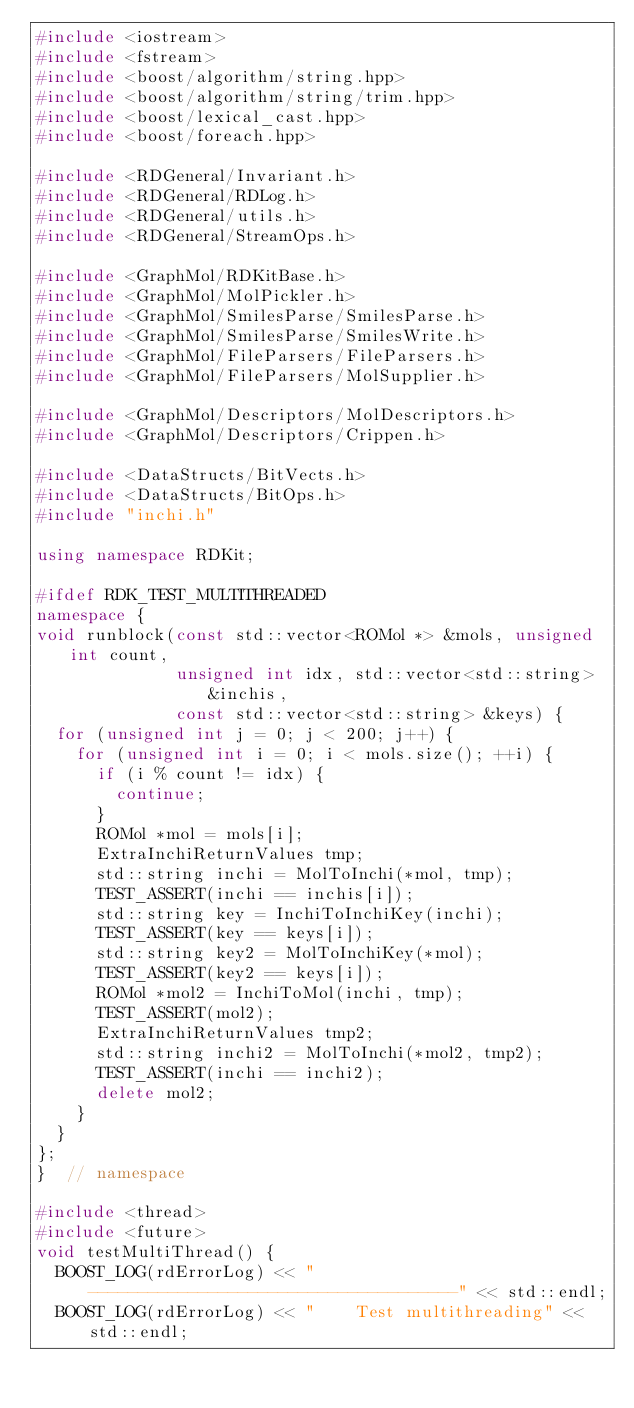Convert code to text. <code><loc_0><loc_0><loc_500><loc_500><_C++_>#include <iostream>
#include <fstream>
#include <boost/algorithm/string.hpp>
#include <boost/algorithm/string/trim.hpp>
#include <boost/lexical_cast.hpp>
#include <boost/foreach.hpp>

#include <RDGeneral/Invariant.h>
#include <RDGeneral/RDLog.h>
#include <RDGeneral/utils.h>
#include <RDGeneral/StreamOps.h>

#include <GraphMol/RDKitBase.h>
#include <GraphMol/MolPickler.h>
#include <GraphMol/SmilesParse/SmilesParse.h>
#include <GraphMol/SmilesParse/SmilesWrite.h>
#include <GraphMol/FileParsers/FileParsers.h>
#include <GraphMol/FileParsers/MolSupplier.h>

#include <GraphMol/Descriptors/MolDescriptors.h>
#include <GraphMol/Descriptors/Crippen.h>

#include <DataStructs/BitVects.h>
#include <DataStructs/BitOps.h>
#include "inchi.h"

using namespace RDKit;

#ifdef RDK_TEST_MULTITHREADED
namespace {
void runblock(const std::vector<ROMol *> &mols, unsigned int count,
              unsigned int idx, std::vector<std::string> &inchis,
              const std::vector<std::string> &keys) {
  for (unsigned int j = 0; j < 200; j++) {
    for (unsigned int i = 0; i < mols.size(); ++i) {
      if (i % count != idx) {
        continue;
      }
      ROMol *mol = mols[i];
      ExtraInchiReturnValues tmp;
      std::string inchi = MolToInchi(*mol, tmp);
      TEST_ASSERT(inchi == inchis[i]);
      std::string key = InchiToInchiKey(inchi);
      TEST_ASSERT(key == keys[i]);
      std::string key2 = MolToInchiKey(*mol);
      TEST_ASSERT(key2 == keys[i]);
      ROMol *mol2 = InchiToMol(inchi, tmp);
      TEST_ASSERT(mol2);
      ExtraInchiReturnValues tmp2;
      std::string inchi2 = MolToInchi(*mol2, tmp2);
      TEST_ASSERT(inchi == inchi2);
      delete mol2;
    }
  }
};
}  // namespace

#include <thread>
#include <future>
void testMultiThread() {
  BOOST_LOG(rdErrorLog) << "-------------------------------------" << std::endl;
  BOOST_LOG(rdErrorLog) << "    Test multithreading" << std::endl;
</code> 